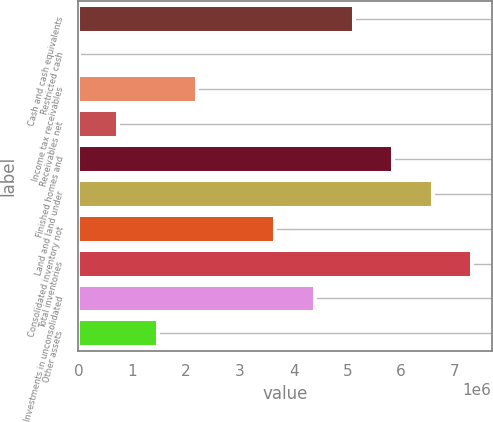Convert chart to OTSL. <chart><loc_0><loc_0><loc_500><loc_500><bar_chart><fcel>Cash and cash equivalents<fcel>Restricted cash<fcel>Income tax receivables<fcel>Receivables net<fcel>Finished homes and<fcel>Land and land under<fcel>Consolidated inventory not<fcel>Total inventories<fcel>Investments in unconsolidated<fcel>Other assets<nl><fcel>5.12312e+06<fcel>9225<fcel>2.20089e+06<fcel>739782<fcel>5.85368e+06<fcel>6.58423e+06<fcel>3.66201e+06<fcel>7.31479e+06<fcel>4.39256e+06<fcel>1.47034e+06<nl></chart> 